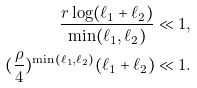<formula> <loc_0><loc_0><loc_500><loc_500>\frac { r \log ( \ell _ { 1 } + \ell _ { 2 } ) } { \min ( \ell _ { 1 } , \ell _ { 2 } ) } & \ll 1 , \\ ( \frac { \rho } { 4 } ) ^ { \min ( \ell _ { 1 } , \ell _ { 2 } ) } ( \ell _ { 1 } + \ell _ { 2 } ) & \ll 1 . \\</formula> 